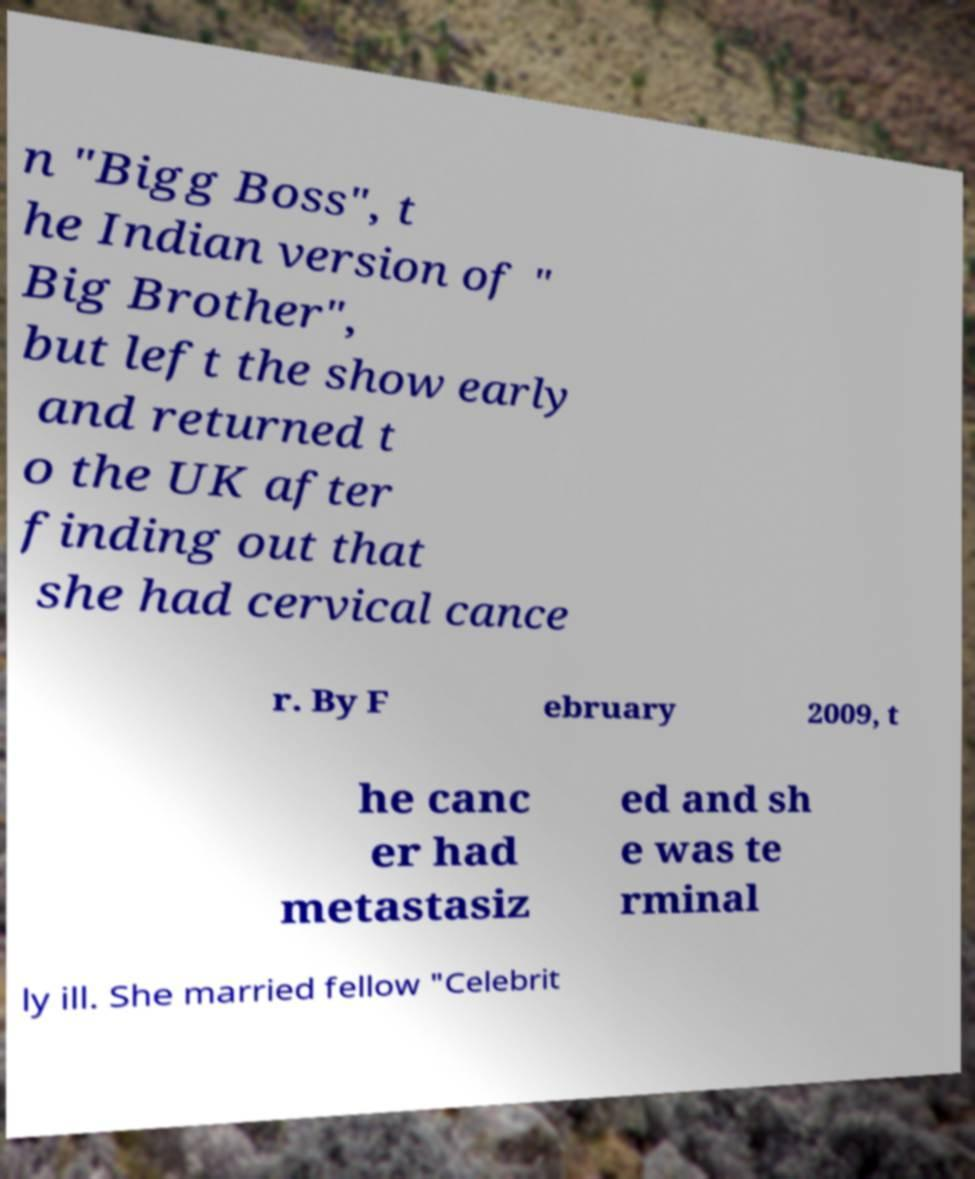Could you extract and type out the text from this image? n "Bigg Boss", t he Indian version of " Big Brother", but left the show early and returned t o the UK after finding out that she had cervical cance r. By F ebruary 2009, t he canc er had metastasiz ed and sh e was te rminal ly ill. She married fellow "Celebrit 